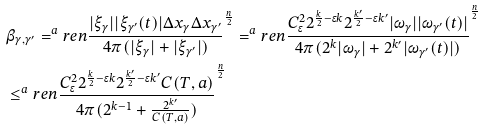Convert formula to latex. <formula><loc_0><loc_0><loc_500><loc_500>& \beta _ { \gamma , \gamma ^ { \prime } } = ^ { a } r e n { \frac { | \xi _ { \gamma } | | \xi _ { \gamma ^ { \prime } } ( t ) | \Delta x _ { \gamma } \Delta x _ { \gamma ^ { \prime } } } { 4 \pi ( | \xi _ { \gamma } | + | \xi _ { \gamma ^ { \prime } } | ) } } ^ { \frac { n } { 2 } } = ^ { a } r e n { \frac { C _ { \epsilon } ^ { 2 } 2 ^ { \frac { k } { 2 } - \epsilon k } 2 ^ { \frac { k ^ { \prime } } { 2 } - \epsilon k ^ { \prime } } | \omega _ { \gamma } | | \omega _ { \gamma ^ { \prime } } ( t ) | } { 4 \pi ( 2 ^ { k } | \omega _ { \gamma } | + 2 ^ { k ^ { \prime } } | \omega _ { \gamma ^ { \prime } } ( t ) | ) } } ^ { \frac { n } { 2 } } \\ & \leq ^ { a } r e n { \frac { C ^ { 2 } _ { \epsilon } 2 ^ { \frac { k } { 2 } - \epsilon k } 2 ^ { \frac { k ^ { \prime } } { 2 } - \epsilon k ^ { \prime } } C ( T , a ) } { 4 \pi ( 2 ^ { k - 1 } + \frac { 2 ^ { k ^ { \prime } } } { C ( T , a ) } ) } } ^ { \frac { n } { 2 } }</formula> 